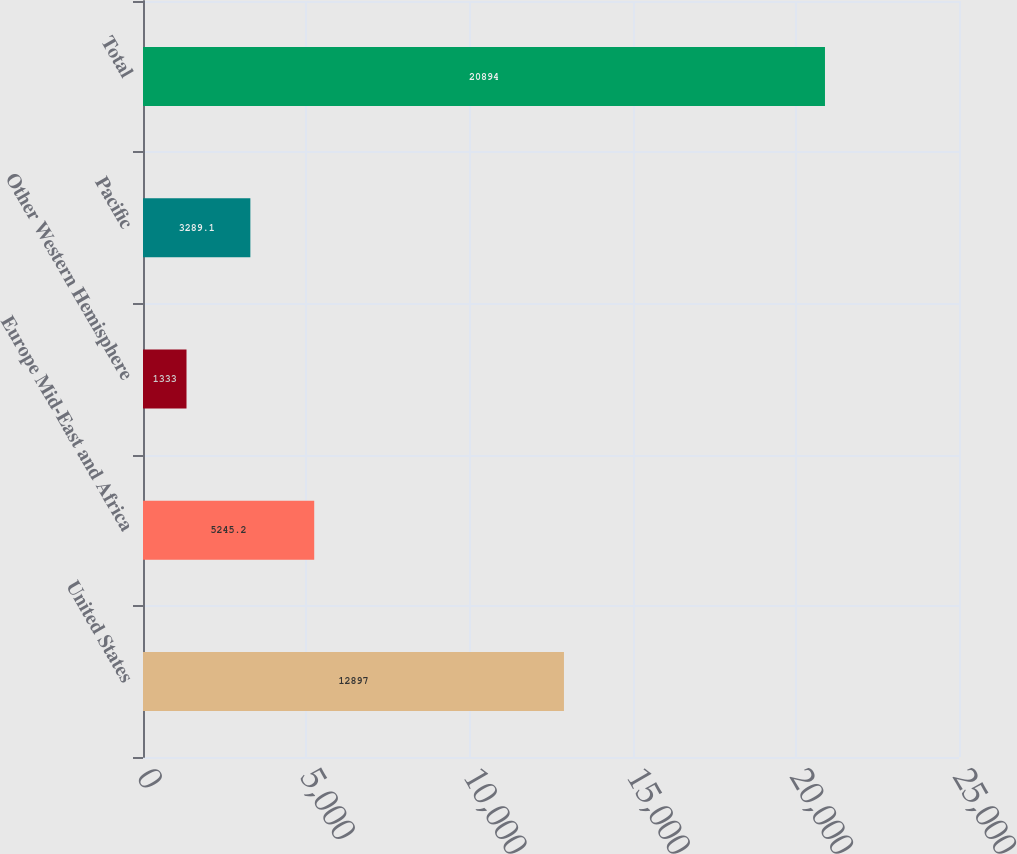<chart> <loc_0><loc_0><loc_500><loc_500><bar_chart><fcel>United States<fcel>Europe Mid-East and Africa<fcel>Other Western Hemisphere<fcel>Pacific<fcel>Total<nl><fcel>12897<fcel>5245.2<fcel>1333<fcel>3289.1<fcel>20894<nl></chart> 